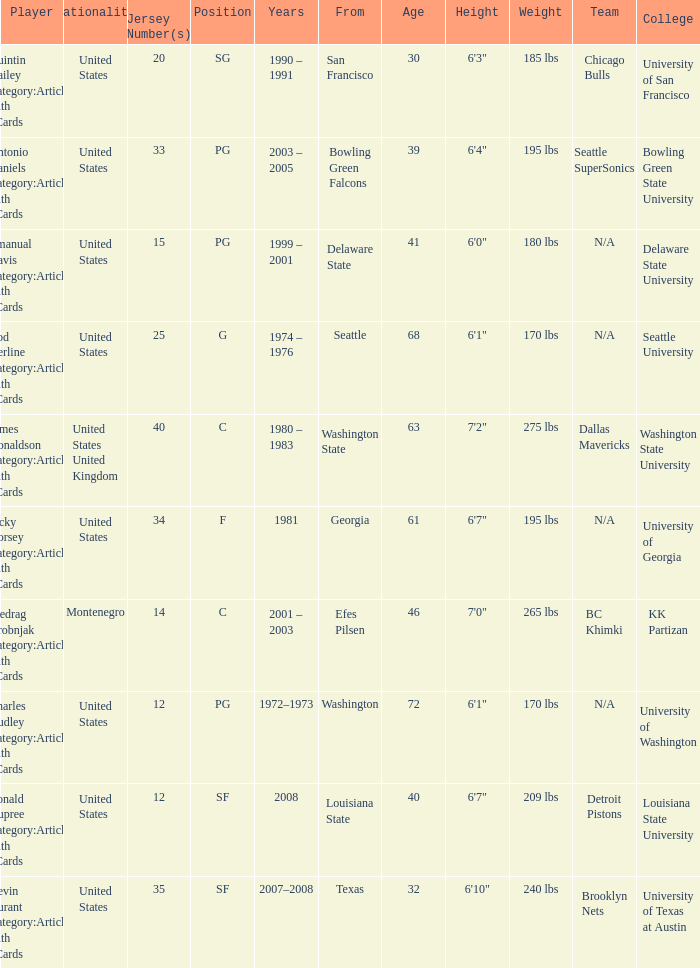I'm looking to parse the entire table for insights. Could you assist me with that? {'header': ['Player', 'Nationality', 'Jersey Number(s)', 'Position', 'Years', 'From', 'Age', 'Height', 'Weight', 'Team', 'College '], 'rows': [['Quintin Dailey Category:Articles with hCards', 'United States', '20', 'SG', '1990 – 1991', 'San Francisco', '30', '6\'3"', '185 lbs', 'Chicago Bulls', 'University of San Francisco'], ['Antonio Daniels Category:Articles with hCards', 'United States', '33', 'PG', '2003 – 2005', 'Bowling Green Falcons', '39', '6\'4"', '195 lbs', 'Seattle SuperSonics', 'Bowling Green State University'], ['Emanual Davis Category:Articles with hCards', 'United States', '15', 'PG', '1999 – 2001', 'Delaware State', '41', '6\'0"', '180 lbs', 'N/A', 'Delaware State University'], ['Rod Derline Category:Articles with hCards', 'United States', '25', 'G', '1974 – 1976', 'Seattle', '68', '6\'1"', '170 lbs', 'N/A', 'Seattle University'], ['James Donaldson Category:Articles with hCards', 'United States United Kingdom', '40', 'C', '1980 – 1983', 'Washington State', '63', '7\'2"', '275 lbs', 'Dallas Mavericks', 'Washington State University'], ['Jacky Dorsey Category:Articles with hCards', 'United States', '34', 'F', '1981', 'Georgia', '61', '6\'7"', '195 lbs', 'N/A', 'University of Georgia'], ['Predrag Drobnjak Category:Articles with hCards', 'Montenegro', '14', 'C', '2001 – 2003', 'Efes Pilsen', '46', '7\'0"', '265 lbs', 'BC Khimki', 'KK Partizan'], ['Charles Dudley Category:Articles with hCards', 'United States', '12', 'PG', '1972–1973', 'Washington', '72', '6\'1"', '170 lbs', 'N/A', 'University of Washington'], ['Ronald Dupree Category:Articles with hCards', 'United States', '12', 'SF', '2008', 'Louisiana State', '40', '6\'7"', '209 lbs', 'Detroit Pistons', 'Louisiana State University'], ['Kevin Durant Category:Articles with hCards', 'United States', '35', 'SF', '2007–2008', 'Texas', '32', '6\'10"', '240 lbs', 'Brooklyn Nets', 'University of Texas at Austin']]} What years did the united states player with a jersey number 25 who attended delaware state play? 1999 – 2001. 